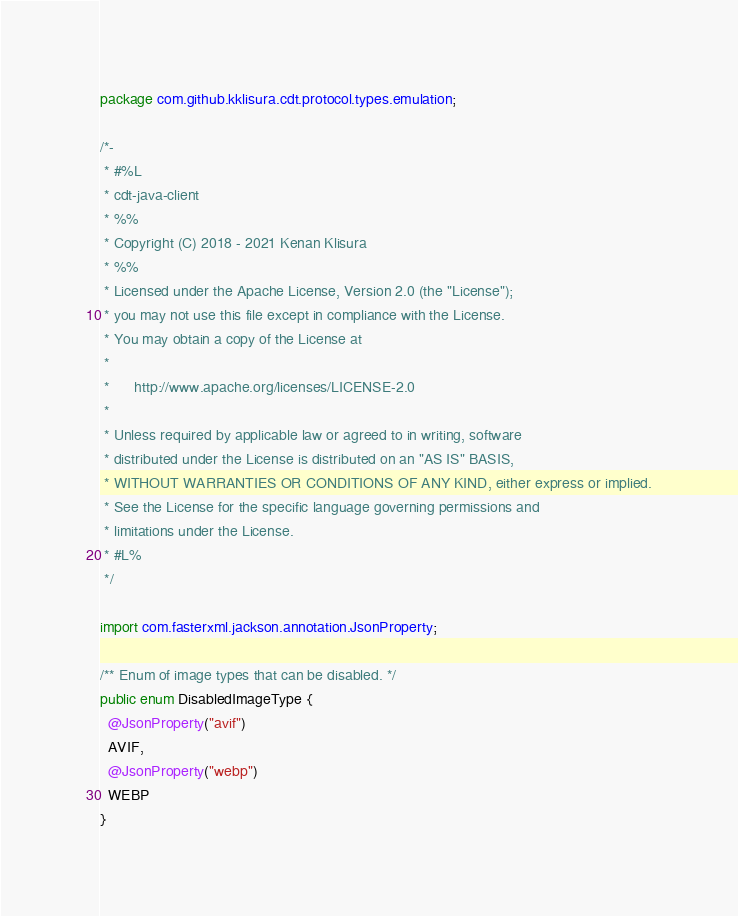Convert code to text. <code><loc_0><loc_0><loc_500><loc_500><_Java_>package com.github.kklisura.cdt.protocol.types.emulation;

/*-
 * #%L
 * cdt-java-client
 * %%
 * Copyright (C) 2018 - 2021 Kenan Klisura
 * %%
 * Licensed under the Apache License, Version 2.0 (the "License");
 * you may not use this file except in compliance with the License.
 * You may obtain a copy of the License at
 *
 *      http://www.apache.org/licenses/LICENSE-2.0
 *
 * Unless required by applicable law or agreed to in writing, software
 * distributed under the License is distributed on an "AS IS" BASIS,
 * WITHOUT WARRANTIES OR CONDITIONS OF ANY KIND, either express or implied.
 * See the License for the specific language governing permissions and
 * limitations under the License.
 * #L%
 */

import com.fasterxml.jackson.annotation.JsonProperty;

/** Enum of image types that can be disabled. */
public enum DisabledImageType {
  @JsonProperty("avif")
  AVIF,
  @JsonProperty("webp")
  WEBP
}
</code> 